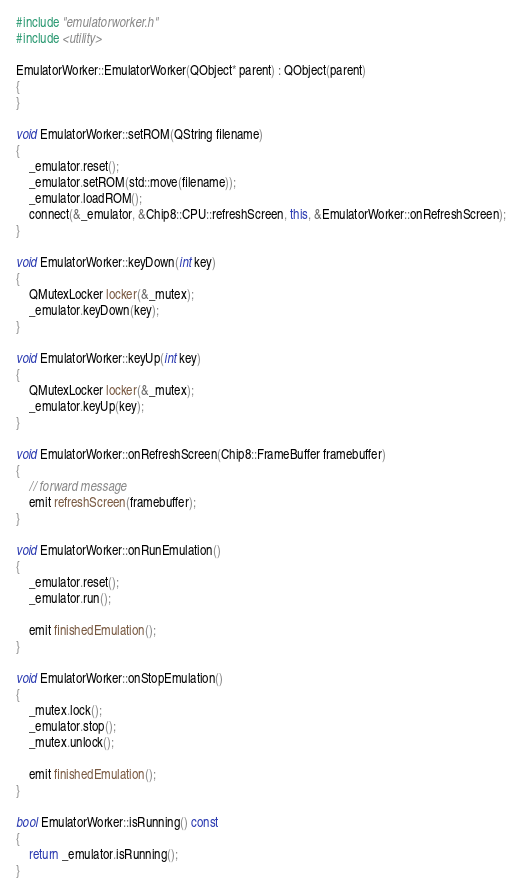<code> <loc_0><loc_0><loc_500><loc_500><_C++_>#include "emulatorworker.h"
#include <utility>

EmulatorWorker::EmulatorWorker(QObject* parent) : QObject(parent)
{
}

void EmulatorWorker::setROM(QString filename)
{
	_emulator.reset();
	_emulator.setROM(std::move(filename));
	_emulator.loadROM();
	connect(&_emulator, &Chip8::CPU::refreshScreen, this, &EmulatorWorker::onRefreshScreen);
}

void EmulatorWorker::keyDown(int key)
{
	QMutexLocker locker(&_mutex);
	_emulator.keyDown(key);
}

void EmulatorWorker::keyUp(int key)
{
	QMutexLocker locker(&_mutex);
	_emulator.keyUp(key);
}

void EmulatorWorker::onRefreshScreen(Chip8::FrameBuffer framebuffer)
{
	// forward message
	emit refreshScreen(framebuffer);
}

void EmulatorWorker::onRunEmulation()
{
	_emulator.reset();
	_emulator.run();

	emit finishedEmulation();
}

void EmulatorWorker::onStopEmulation()
{
	_mutex.lock();
	_emulator.stop();
	_mutex.unlock();

	emit finishedEmulation();
}

bool EmulatorWorker::isRunning() const
{
	return _emulator.isRunning();
}
</code> 